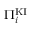Convert formula to latex. <formula><loc_0><loc_0><loc_500><loc_500>\Pi _ { i } ^ { K I }</formula> 